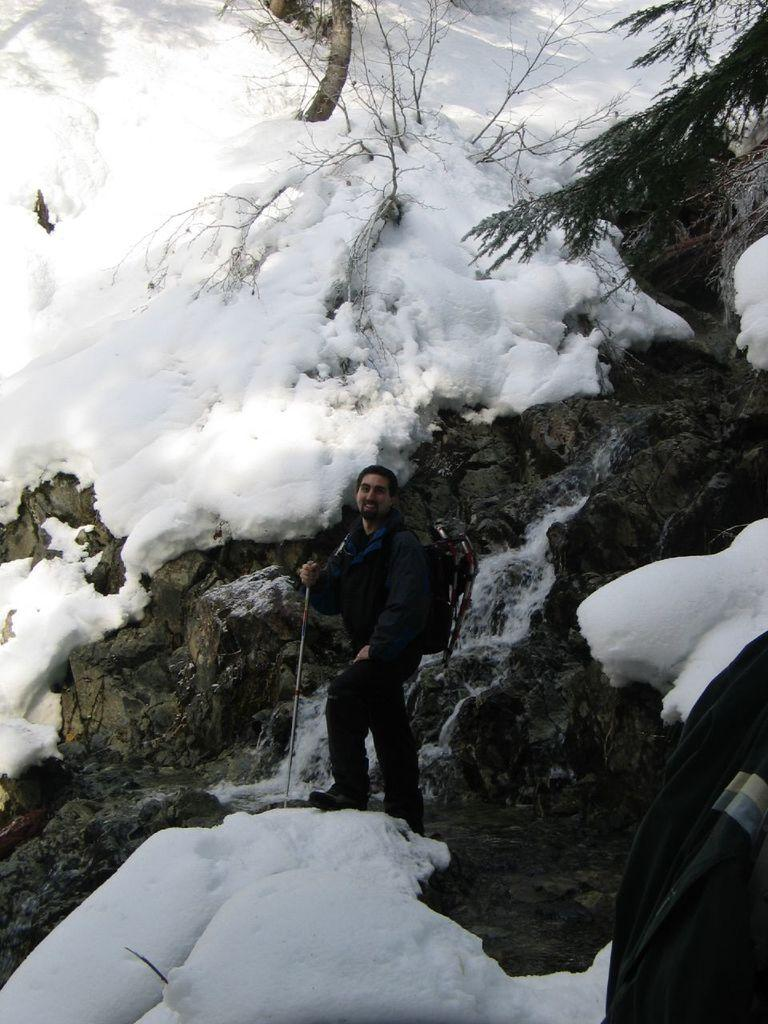Who or what is present in the image? There is a person in the image. What is the person wearing? The person is wearing a jacket. What is the person holding in the image? The person is holding a stick. What is the person standing on? The person is standing on rocks. What is the condition of the rocks? There is snow on the rocks. What can be seen in the background of the image? There are trees visible in the image. What type of circle can be seen on the sheet in the image? There is no sheet or circle present in the image. 